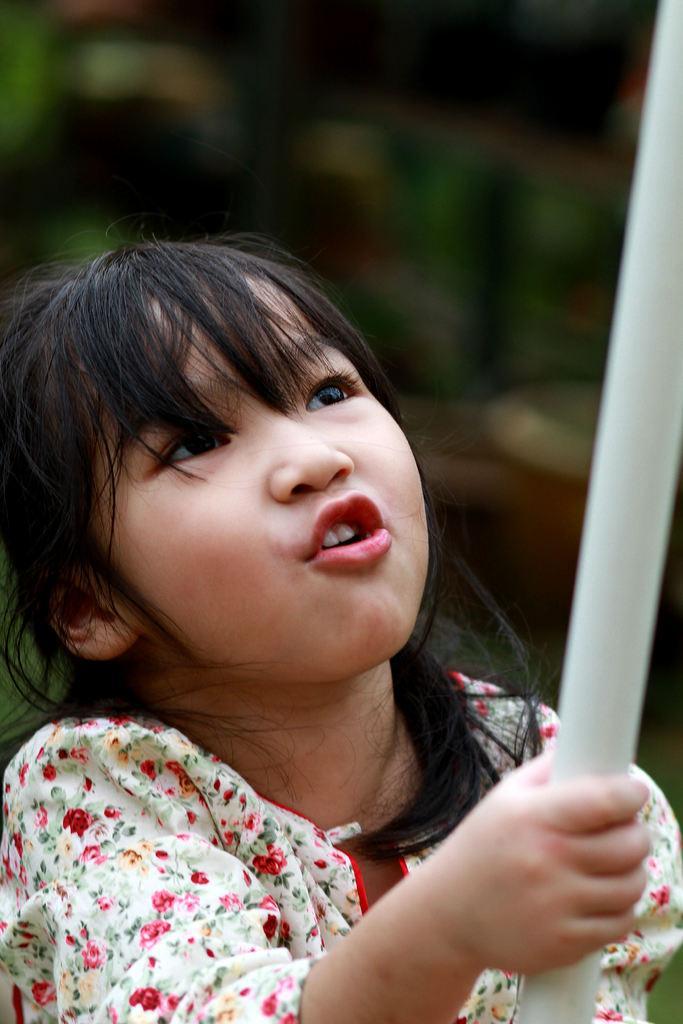Describe this image in one or two sentences. In this picture I can see a girl holding an object, and there is blur background. 